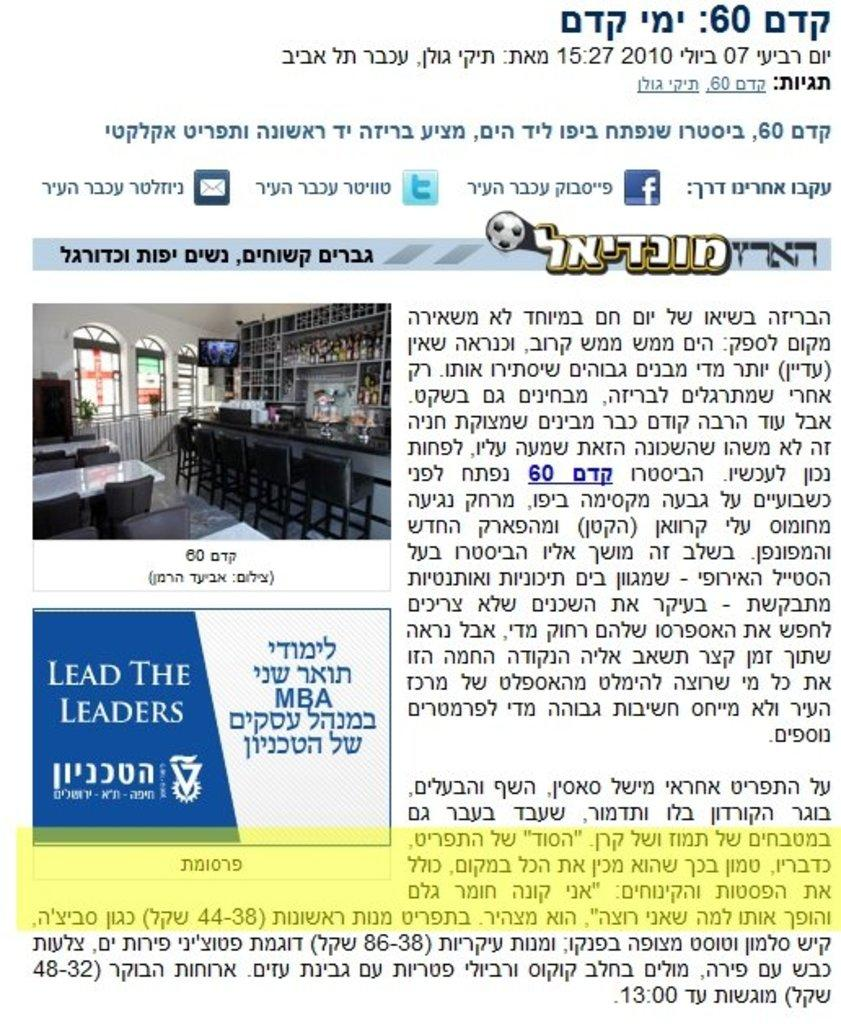<image>
Render a clear and concise summary of the photo. an ad for lead the leaders in a magazine 